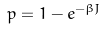<formula> <loc_0><loc_0><loc_500><loc_500>p = 1 - e ^ { - \beta J }</formula> 